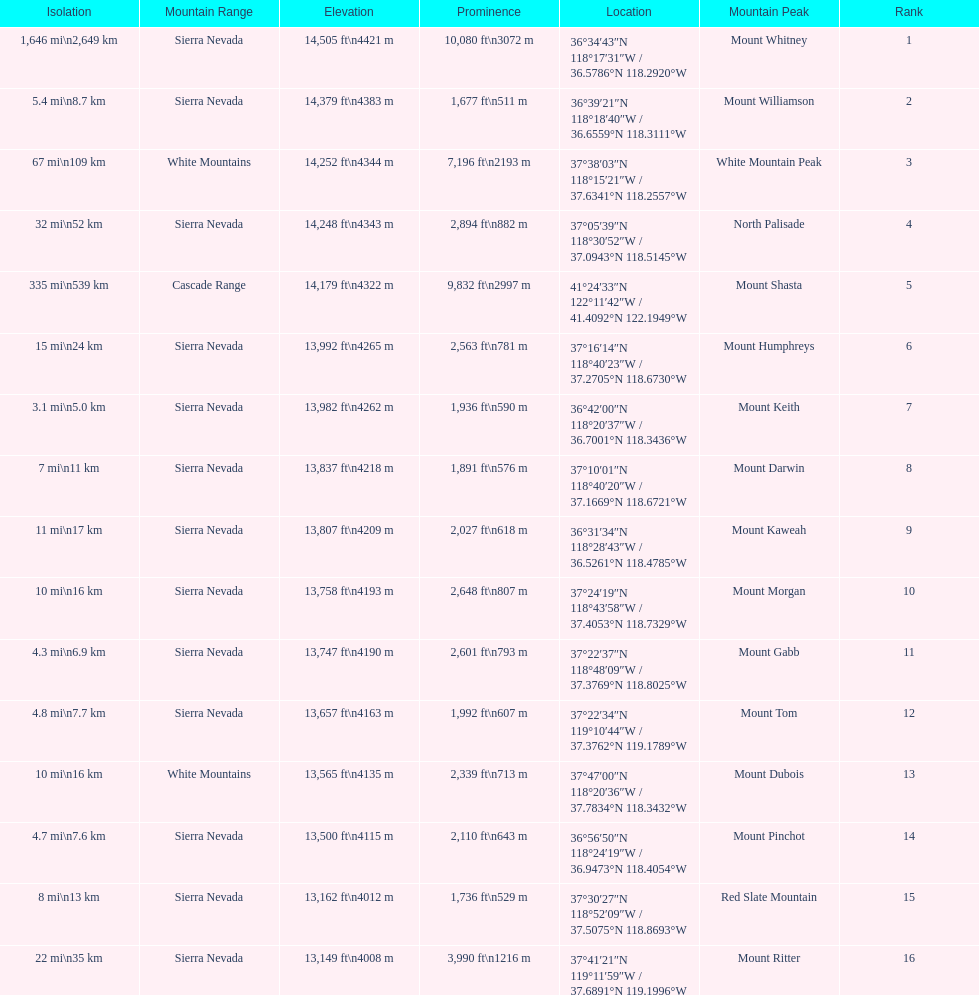What is the tallest peak in the sierra nevadas? Mount Whitney. 